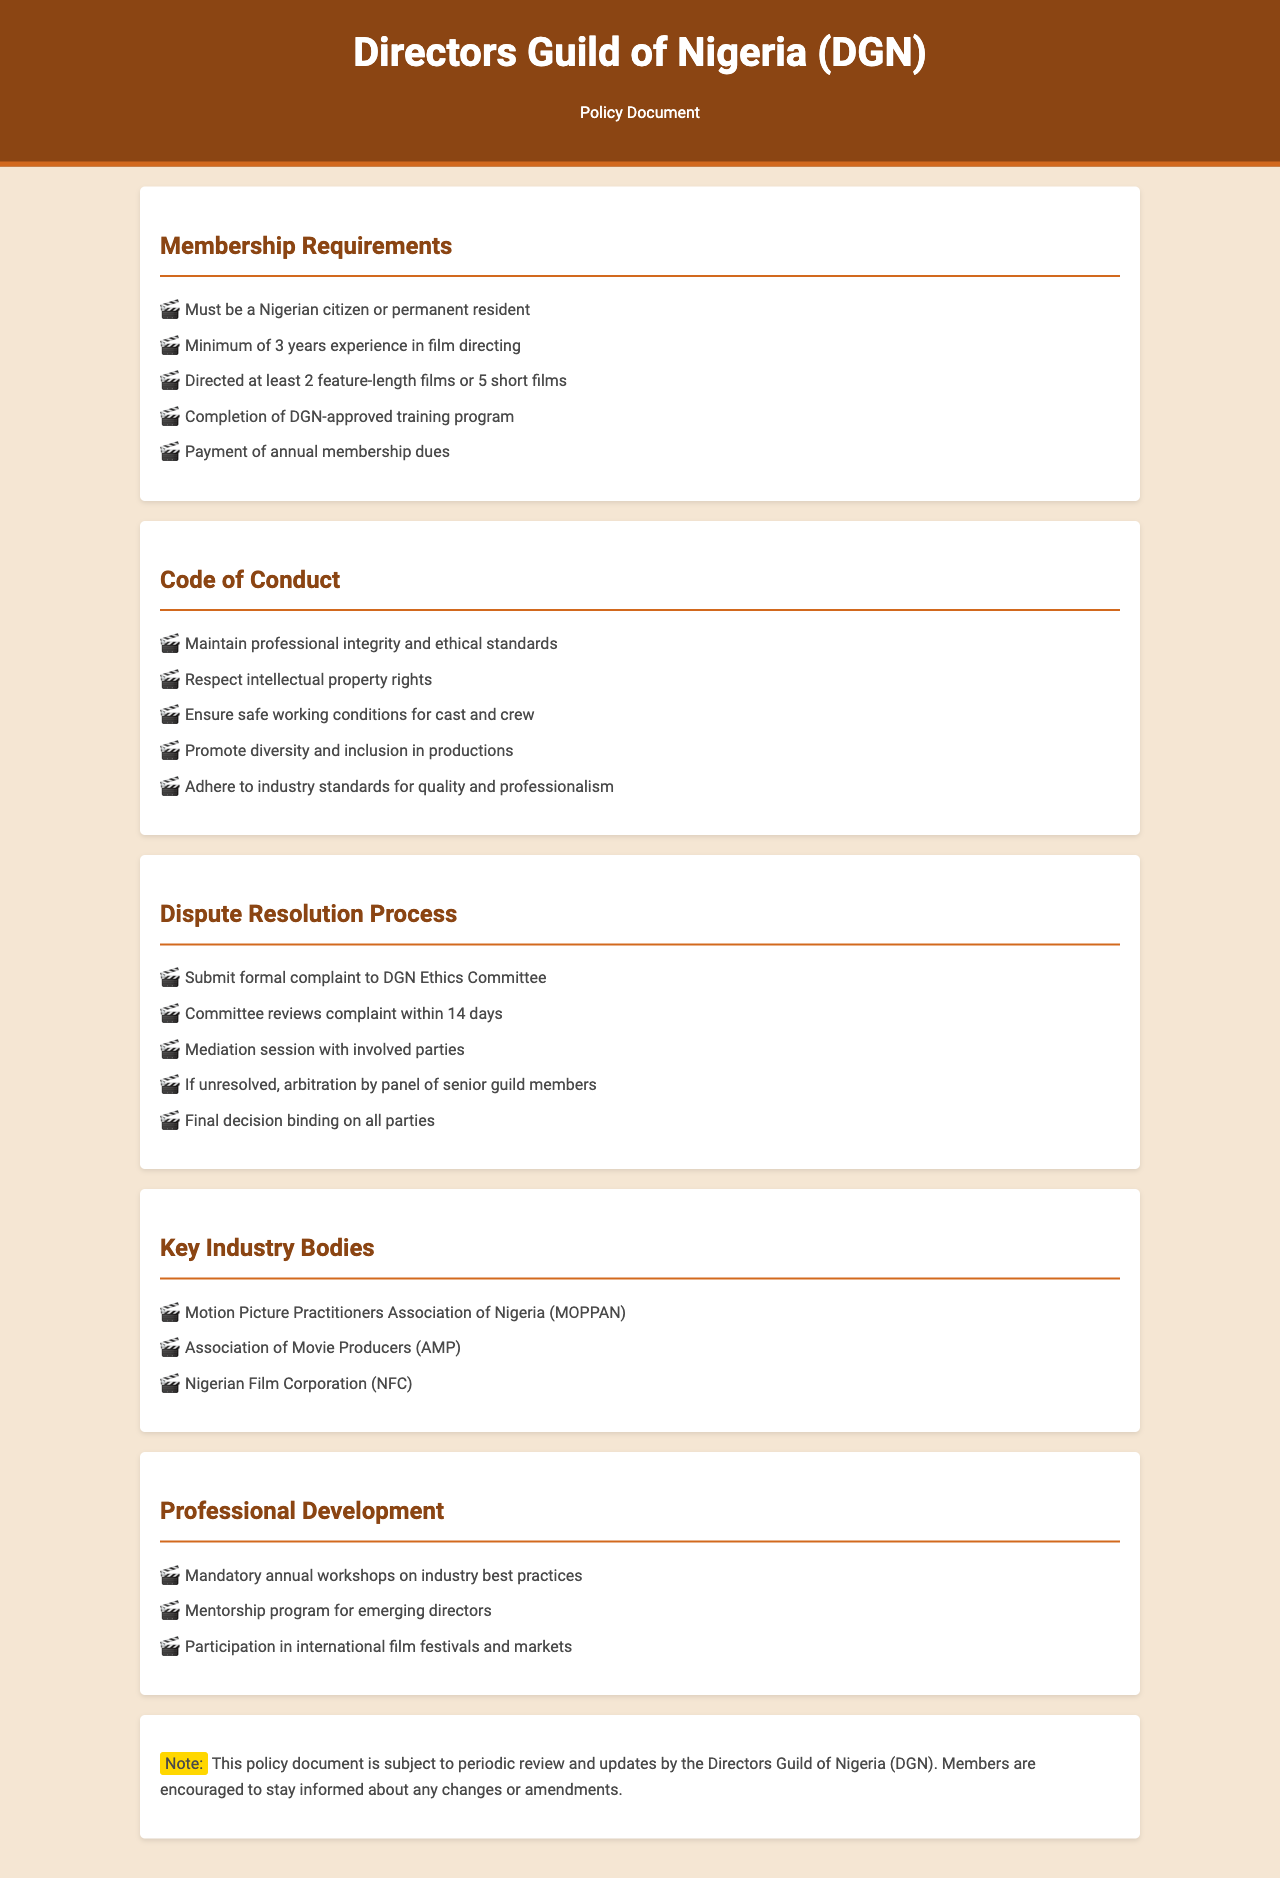What is the minimum experience required for membership? The document states that a minimum of 3 years experience in film directing is required for membership.
Answer: 3 years How many feature-length films must a member have directed? The policy document specifies that a member must have directed at least 2 feature-length films to meet the membership requirements.
Answer: 2 feature-length films What is one key responsibility outlined in the code of conduct? The code of conduct includes maintaining professional integrity and ethical standards as a key responsibility for members.
Answer: Maintain professional integrity What is the first step in the dispute resolution process? According to the document, the first step in the dispute resolution process is to submit a formal complaint to the DGN Ethics Committee.
Answer: Submit formal complaint How long does the Ethics Committee take to review a complaint? The document mentions that the Ethics Committee reviews the complaint within 14 days.
Answer: 14 days Name one of the key industry bodies mentioned in the document. The document lists the Motion Picture Practitioners Association of Nigeria (MOPPAN) as one of the key industry bodies.
Answer: MOPPAN What is required for professional development annually? The document states that mandatory annual workshops on industry best practices are required for professional development.
Answer: Mandatory annual workshops What is the purpose of the mentorship program? The mentorship program is aimed at supporting emerging directors as stated in the professional development section.
Answer: Support emerging directors What should members do to stay informed about policy changes? Members are encouraged to stay informed about any changes or amendments to the policy document.
Answer: Stay informed 